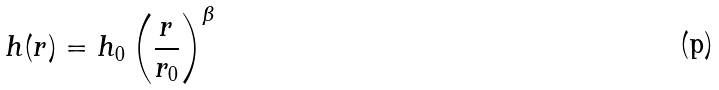Convert formula to latex. <formula><loc_0><loc_0><loc_500><loc_500>h ( r ) = h _ { 0 } \left ( \frac { r } { r _ { 0 } } \right ) ^ { \beta }</formula> 